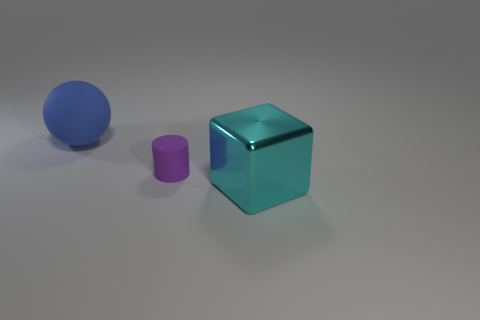Add 3 blue things. How many objects exist? 6 Subtract all spheres. How many objects are left? 2 Subtract all brown rubber cylinders. Subtract all large objects. How many objects are left? 1 Add 3 large metallic cubes. How many large metallic cubes are left? 4 Add 3 purple cylinders. How many purple cylinders exist? 4 Subtract 0 green cylinders. How many objects are left? 3 